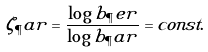<formula> <loc_0><loc_0><loc_500><loc_500>\zeta _ { \P } a r = \frac { \log b _ { \P } e r } { \log b _ { \P } a r } = c o n s t .</formula> 